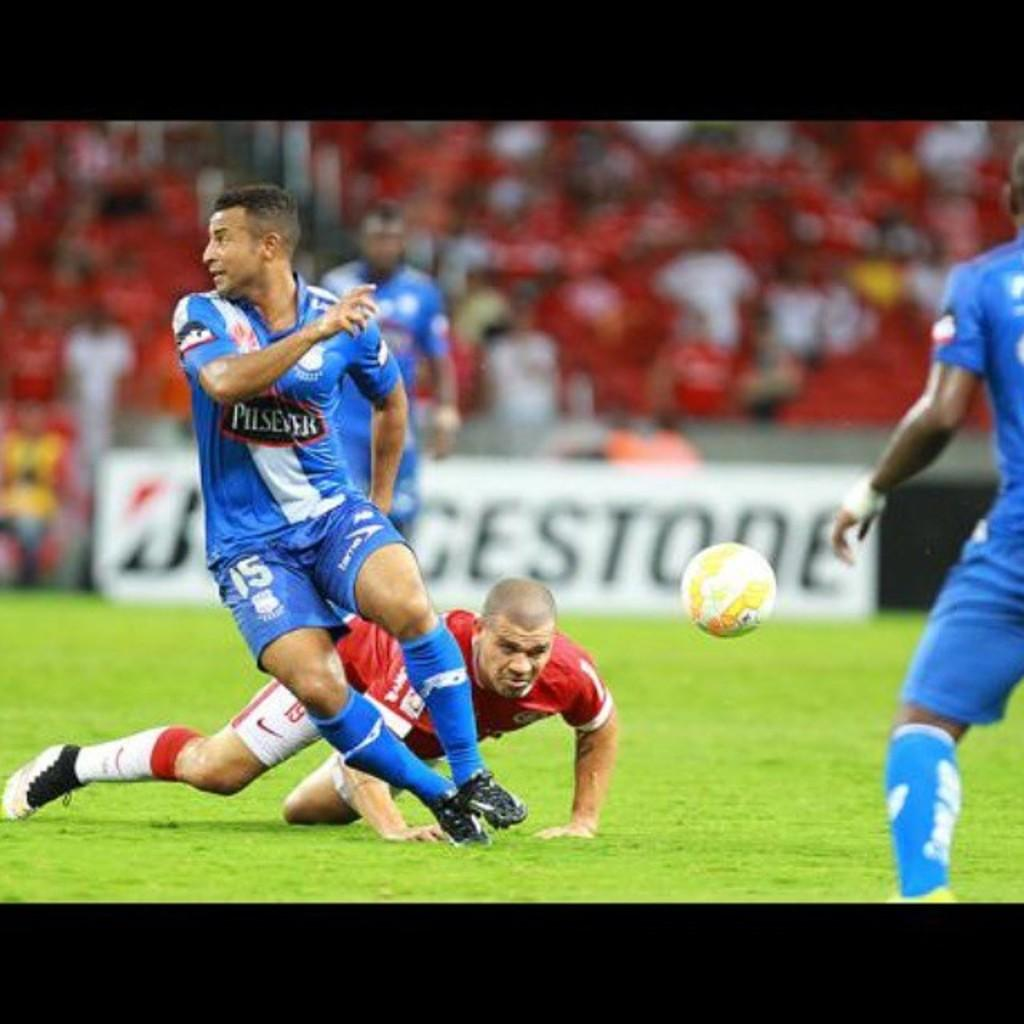Provide a one-sentence caption for the provided image. A bunch of athletes playing on a field sponsored by Bridgestone. 